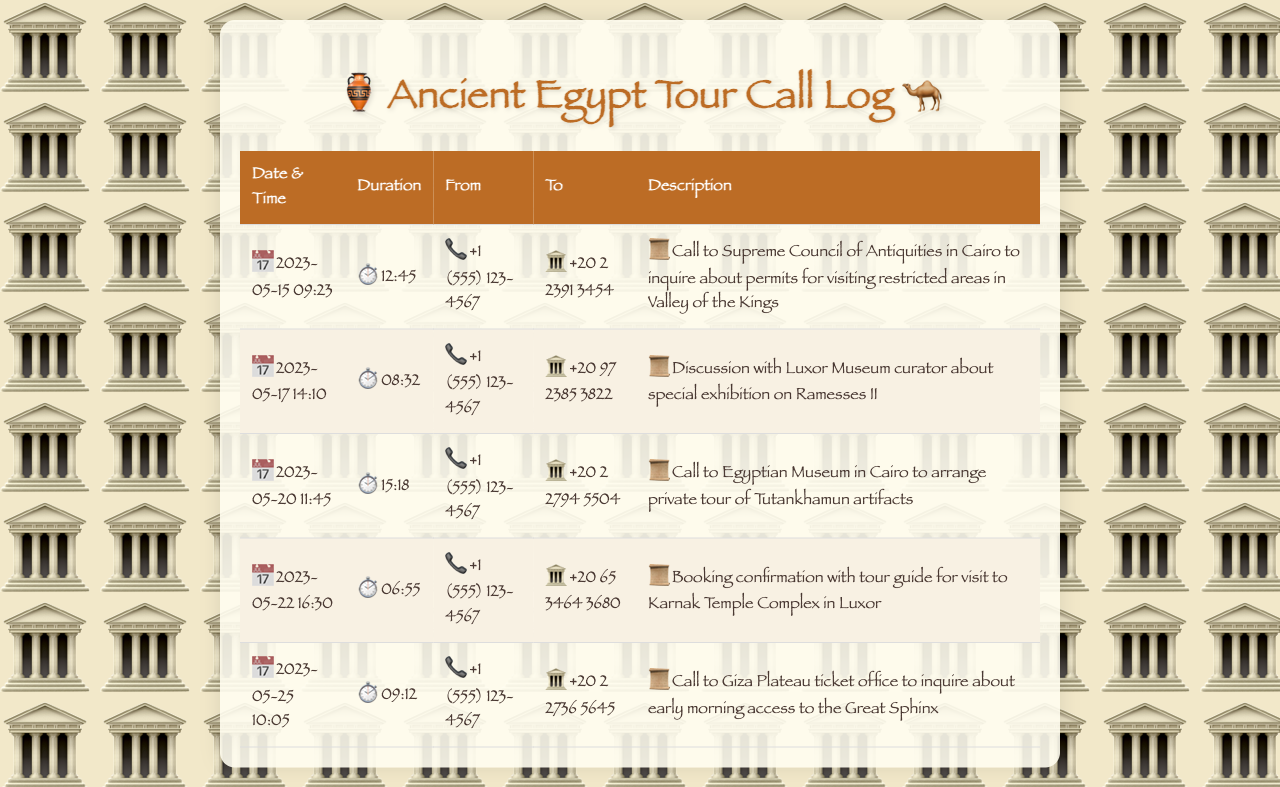What date was the call to the Supreme Council of Antiquities made? The date of the call is listed in the document as 2023-05-15.
Answer: 2023-05-15 How long did the call to Luxor Museum last? The duration of the call is provided as 08:32.
Answer: 08:32 Who was the call to arrange a private tour with? The call was made to the Egyptian Museum in Cairo regarding Tutankhamun artifacts.
Answer: Egyptian Museum What time was the call made to inquire about early morning access to the Great Sphinx? The time of the call is noted as 10:05 on 2023-05-25.
Answer: 10:05 What is the total number of calls listed in the document? The document lists five separate calls regarding different inquiries and arrangements.
Answer: 5 What type of discussion took place during the call on 2023-05-17? The discussion was about a special exhibition on Ramesses II.
Answer: special exhibition on Ramesses II How long was the call made for booking confirmation with the tour guide? The duration of that call is listed as 06:55.
Answer: 06:55 What organization was contacted for permits to visit the Valley of the Kings? The organization contacted was the Supreme Council of Antiquities in Cairo.
Answer: Supreme Council of Antiquities 